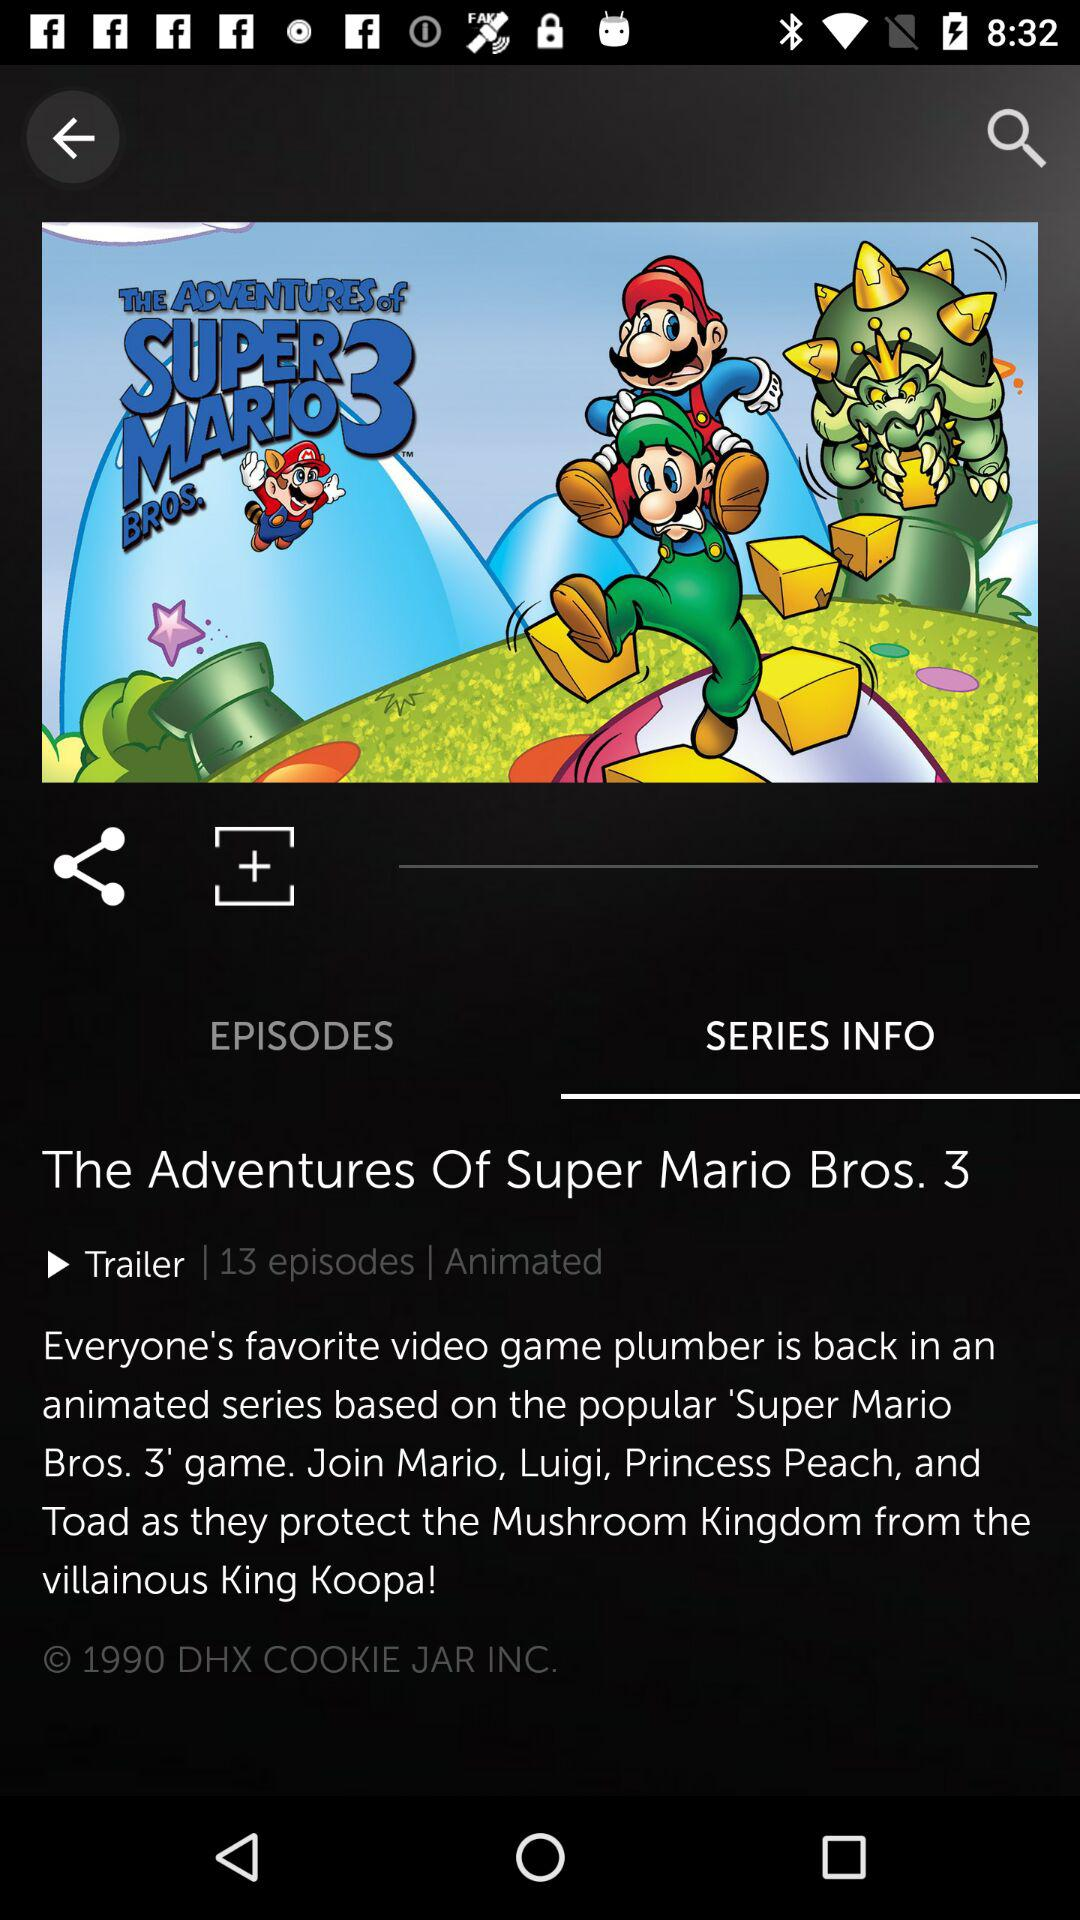What is the series name? The series name is "The Adventures Of Super Mario Bros. 3". 